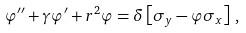Convert formula to latex. <formula><loc_0><loc_0><loc_500><loc_500>\varphi ^ { \prime \prime } + \gamma \varphi ^ { \prime } + r ^ { 2 } \varphi = \delta \left [ \sigma _ { y } - \varphi \sigma _ { x } \right ] \, ,</formula> 